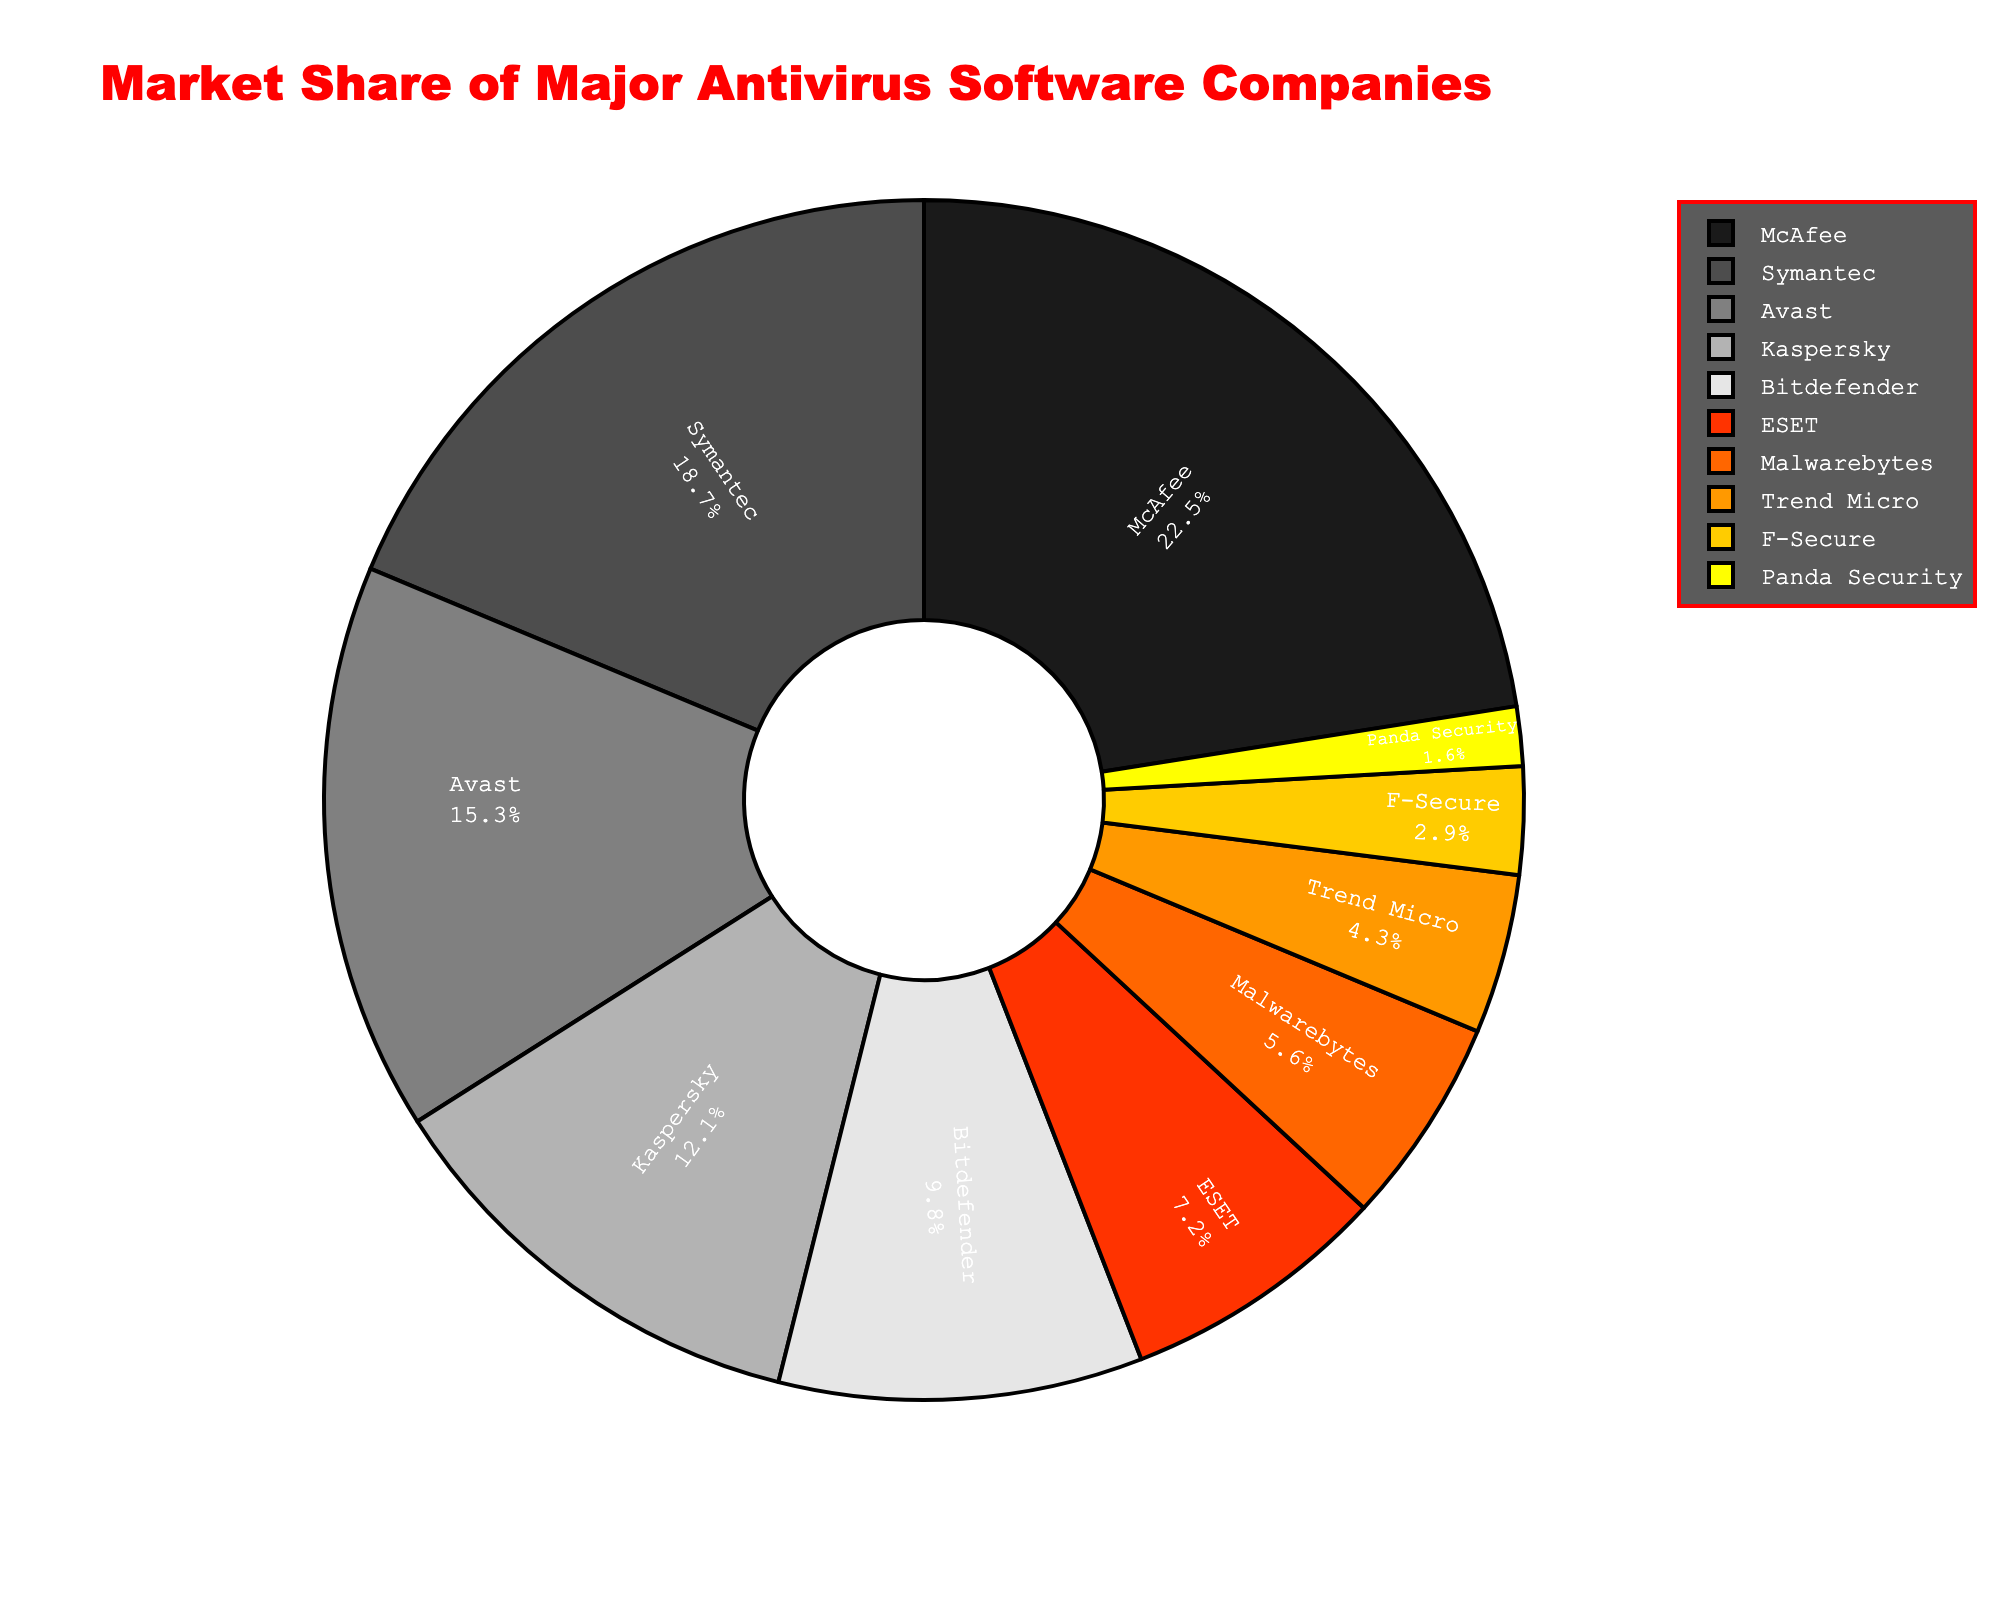What's the market share of McAfee? To find the market share of McAfee, locate "McAfee" on the pie chart and refer to the corresponding market share value. The slice labeled "McAfee" represents 22.5% of the market.
Answer: 22.5% Which company has the smallest market share? Identify the smallest slice by comparing all slices in the pie chart. The slice labeled "Panda Security" is the smallest, representing 1.6% of the market.
Answer: Panda Security What is the combined market share of the top three antivirus companies? Find the market shares of the top three companies: McAfee (22.5%), Symantec (18.7%), and Avast (15.3%). Add these values together: 22.5 + 18.7 + 15.3 = 56.5%.
Answer: 56.5% How does the market share of Kaspersky compare to Bitdefender? Locate the slices for Kaspersky and Bitdefender. Kaspersky's market share is 12.1%, while Bitdefender's is 9.8%. Since 12.1% is greater than 9.8%, Kaspersky has a higher market share.
Answer: Kaspersky has a higher market share What proportion of the market is held by companies aside from the top five? First, find the combined market share of the top five companies: McAfee (22.5%), Symantec (18.7%), Avast (15.3%), Kaspersky (12.1%), and Bitdefender (9.8%). Add these values: 22.5 + 18.7 + 15.3 + 12.1 + 9.8 = 78.4%. Subtract this from 100% to get the share of the remaining companies: 100 - 78.4 = 21.6%.
Answer: 21.6% Which company has a market share closest to 10%? Compare all the slices to see which company's market share is closest to 10%. Bitdefender has a market share of 9.8%, which is closest to 10%.
Answer: Bitdefender Between ESET and Malwarebytes, which one holds a larger market share and by how much? Find the market shares for ESET (7.2%) and Malwarebytes (5.6%). Subtract the smaller value from the larger one: 7.2 - 5.6 = 1.6%.
Answer: ESET by 1.6% If the market is to be equally shared by four companies, what would be the required market share for each? Divide the total market equally among four companies. Each share would be 100 / 4 = 25%.
Answer: 25% What percentage of the market is held by companies with less than 10% market share each? Identify companies with market shares less than 10%: ESET (7.2%), Malwarebytes (5.6%), Trend Micro (4.3%), F-Secure (2.9%), and Panda Security (1.6%). Add these values together: 7.2 + 5.6 + 4.3 + 2.9 + 1.6 = 21.6%.
Answer: 21.6% Which slice is the second largest and what is its market share? Find the slice that is the second largest after McAfee (22.5%). The second largest slice is Symantec with a market share of 18.7%.
Answer: Symantec, 18.7% 